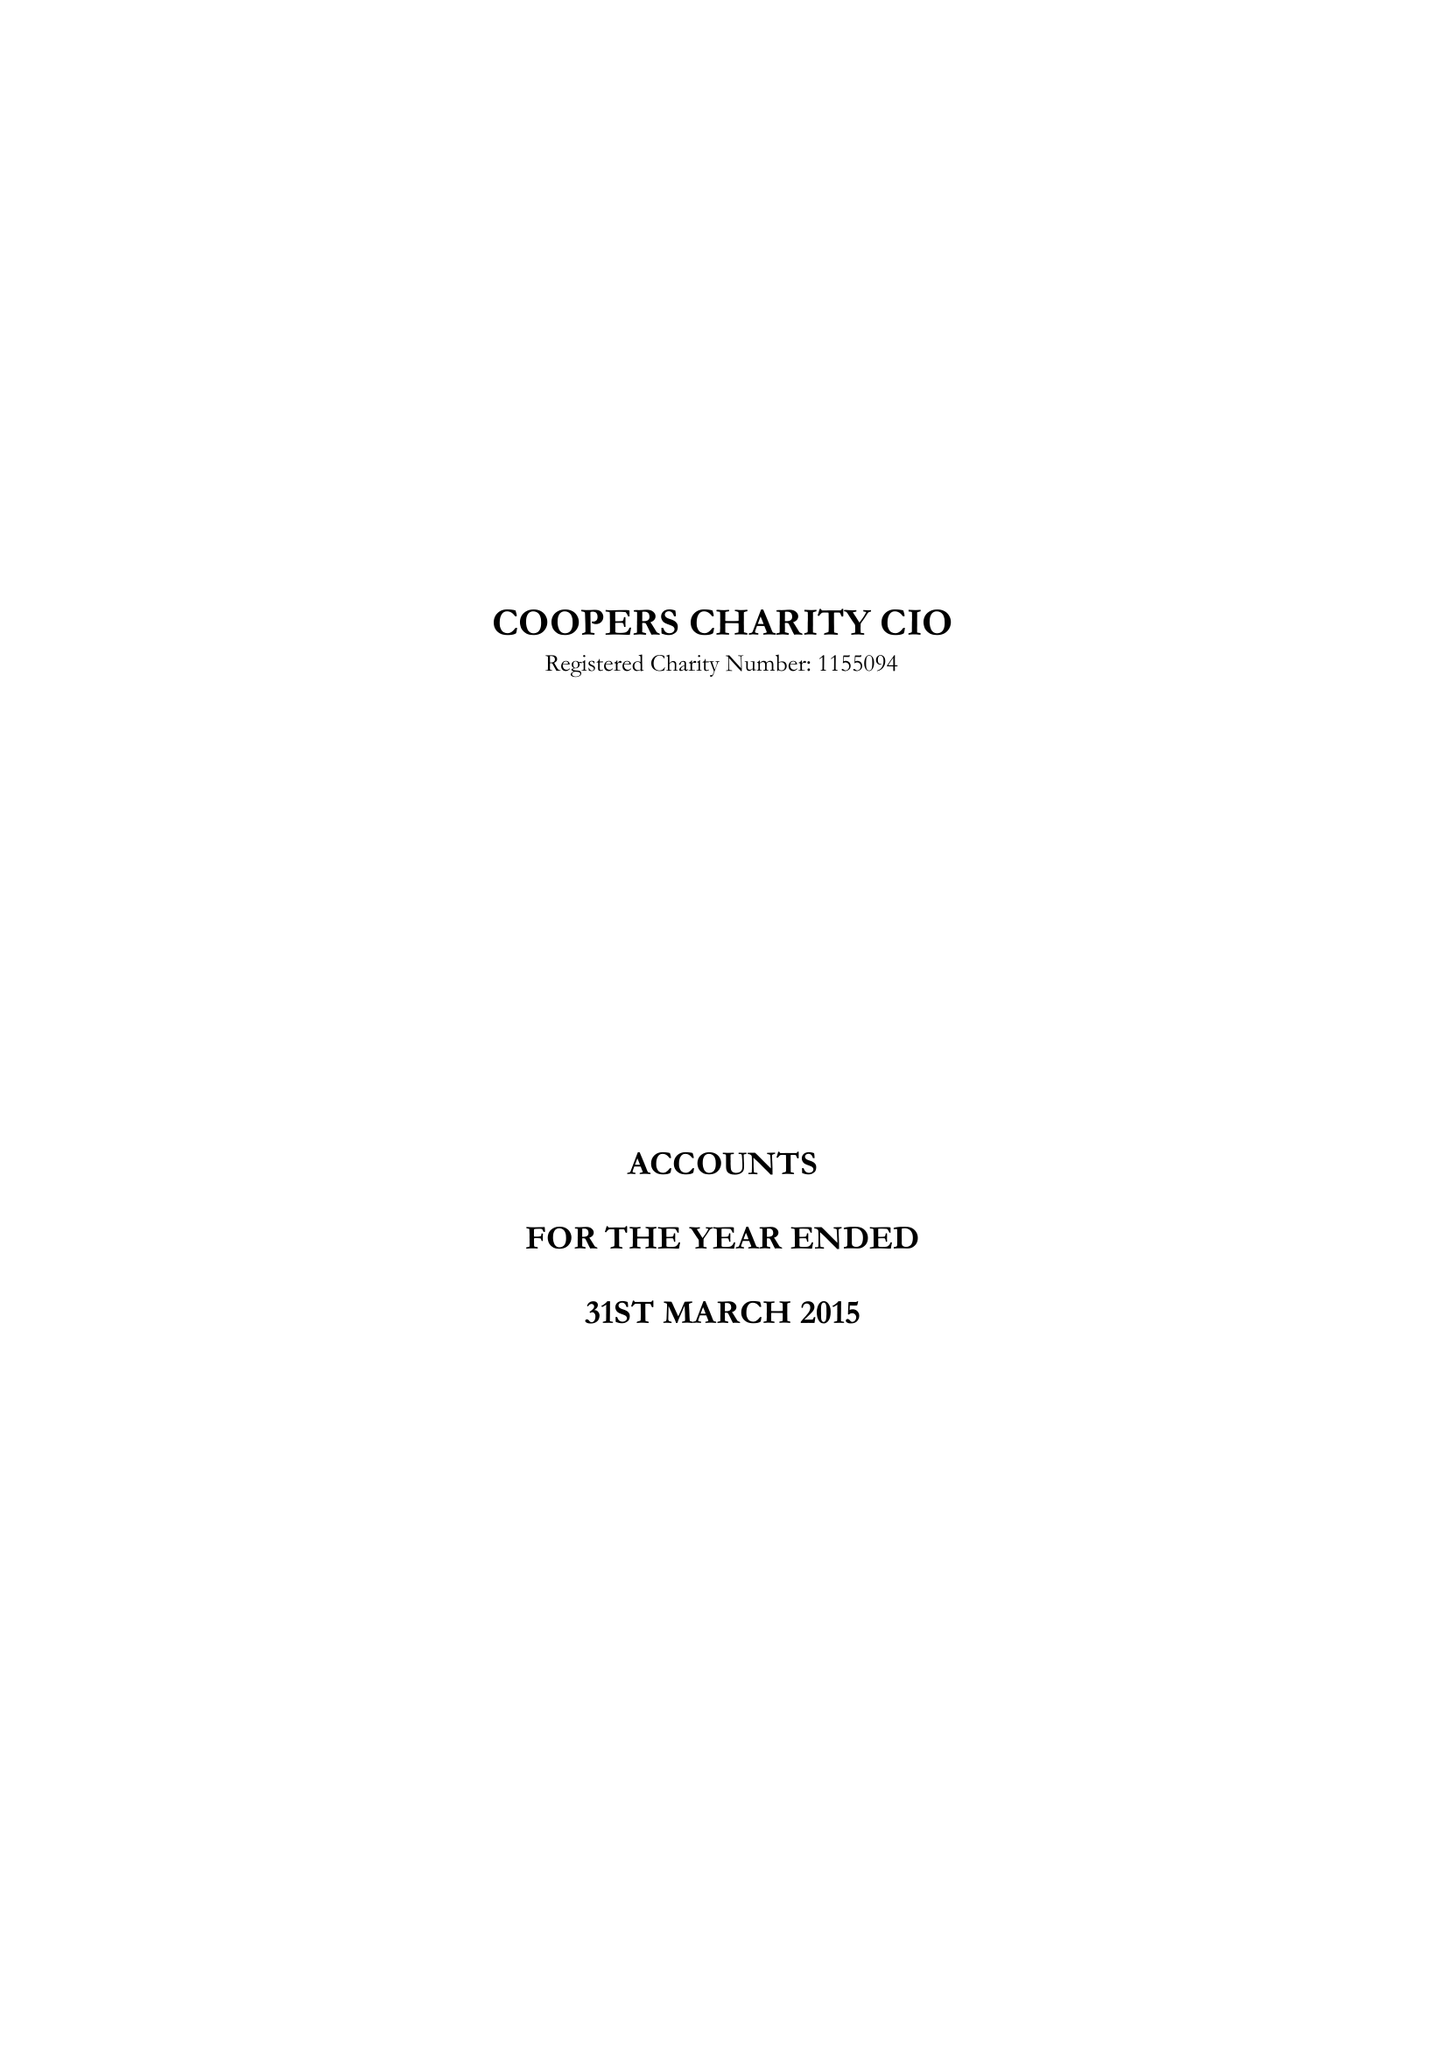What is the value for the charity_name?
Answer the question using a single word or phrase. Coopers Charity CIO 